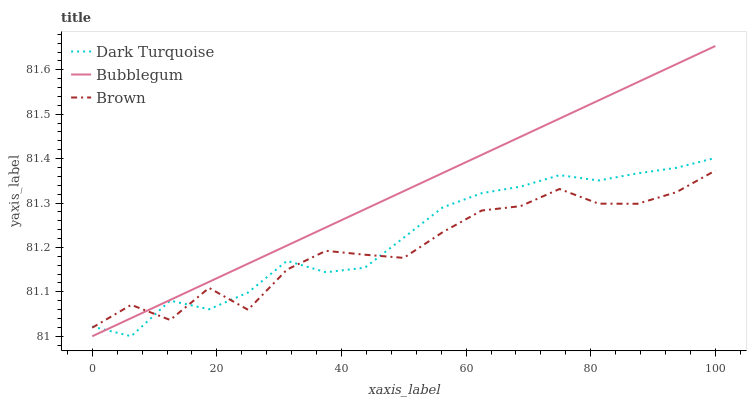Does Brown have the minimum area under the curve?
Answer yes or no. Yes. Does Bubblegum have the maximum area under the curve?
Answer yes or no. Yes. Does Bubblegum have the minimum area under the curve?
Answer yes or no. No. Does Brown have the maximum area under the curve?
Answer yes or no. No. Is Bubblegum the smoothest?
Answer yes or no. Yes. Is Brown the roughest?
Answer yes or no. Yes. Is Brown the smoothest?
Answer yes or no. No. Is Bubblegum the roughest?
Answer yes or no. No. Does Dark Turquoise have the lowest value?
Answer yes or no. Yes. Does Brown have the lowest value?
Answer yes or no. No. Does Bubblegum have the highest value?
Answer yes or no. Yes. Does Brown have the highest value?
Answer yes or no. No. Does Bubblegum intersect Brown?
Answer yes or no. Yes. Is Bubblegum less than Brown?
Answer yes or no. No. Is Bubblegum greater than Brown?
Answer yes or no. No. 